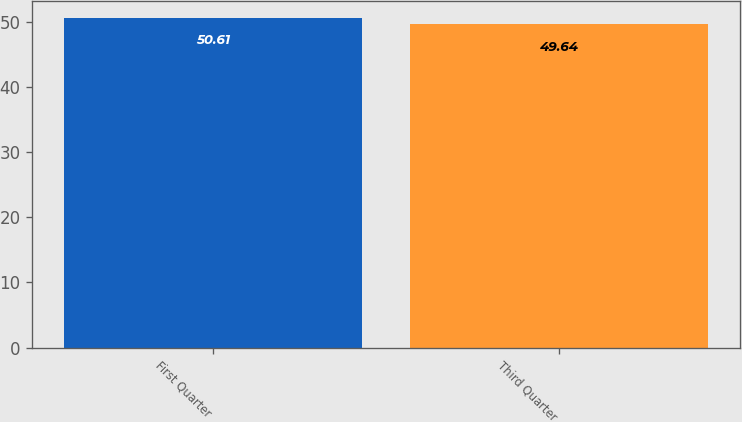Convert chart. <chart><loc_0><loc_0><loc_500><loc_500><bar_chart><fcel>First Quarter<fcel>Third Quarter<nl><fcel>50.61<fcel>49.64<nl></chart> 